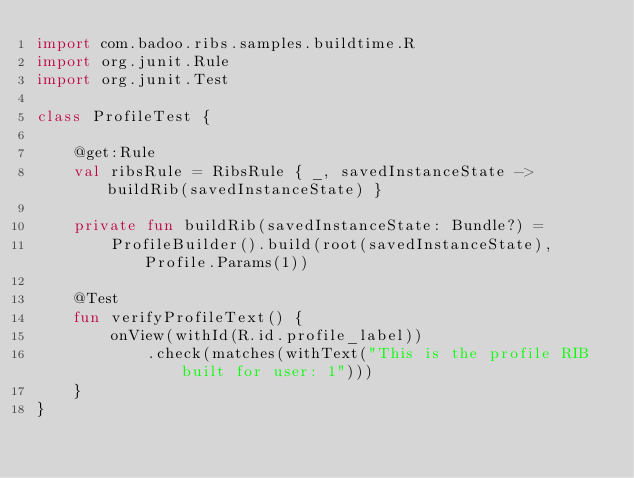<code> <loc_0><loc_0><loc_500><loc_500><_Kotlin_>import com.badoo.ribs.samples.buildtime.R
import org.junit.Rule
import org.junit.Test

class ProfileTest {

    @get:Rule
    val ribsRule = RibsRule { _, savedInstanceState -> buildRib(savedInstanceState) }

    private fun buildRib(savedInstanceState: Bundle?) =
        ProfileBuilder().build(root(savedInstanceState), Profile.Params(1))

    @Test
    fun verifyProfileText() {
        onView(withId(R.id.profile_label))
            .check(matches(withText("This is the profile RIB built for user: 1")))
    }
}
</code> 